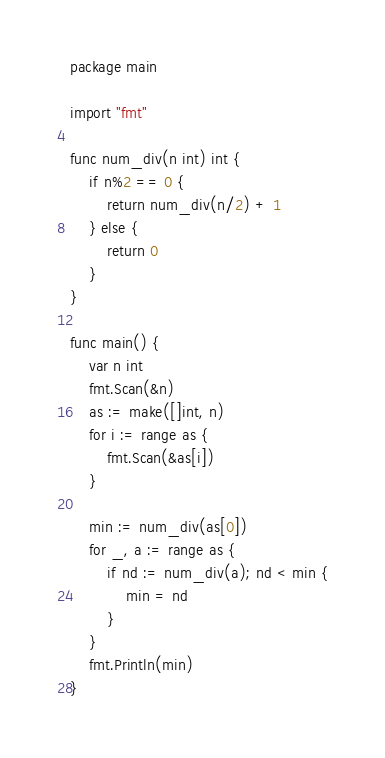<code> <loc_0><loc_0><loc_500><loc_500><_Go_>package main

import "fmt"

func num_div(n int) int {
	if n%2 == 0 {
		return num_div(n/2) + 1
	} else {
		return 0
	}
}

func main() {
	var n int
	fmt.Scan(&n)
	as := make([]int, n)
	for i := range as {
		fmt.Scan(&as[i])
	}

	min := num_div(as[0])
	for _, a := range as {
		if nd := num_div(a); nd < min {
			min = nd
		}
	}
	fmt.Println(min)
}
</code> 